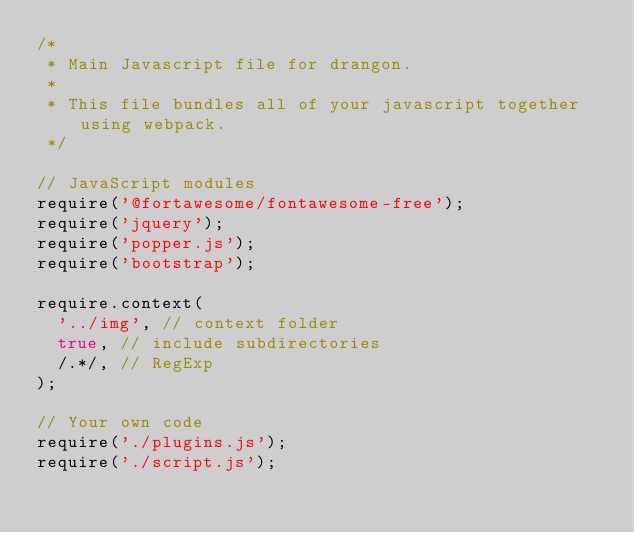Convert code to text. <code><loc_0><loc_0><loc_500><loc_500><_JavaScript_>/*
 * Main Javascript file for drangon.
 *
 * This file bundles all of your javascript together using webpack.
 */

// JavaScript modules
require('@fortawesome/fontawesome-free');
require('jquery');
require('popper.js');
require('bootstrap');

require.context(
  '../img', // context folder
  true, // include subdirectories
  /.*/, // RegExp
);

// Your own code
require('./plugins.js');
require('./script.js');
</code> 